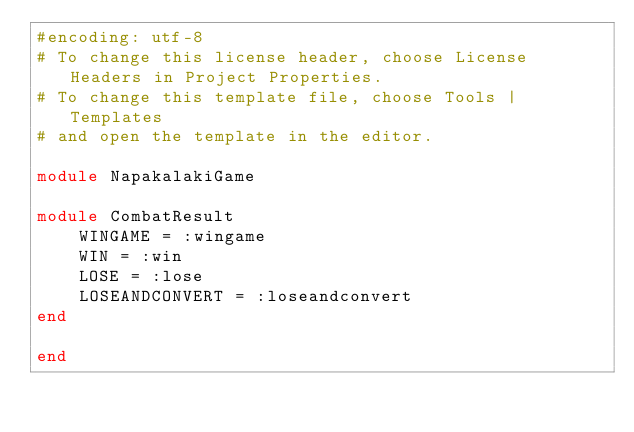Convert code to text. <code><loc_0><loc_0><loc_500><loc_500><_Ruby_>#encoding: utf-8
# To change this license header, choose License Headers in Project Properties.
# To change this template file, choose Tools | Templates
# and open the template in the editor.

module NapakalakiGame

module CombatResult
    WINGAME = :wingame
    WIN = :win
    LOSE = :lose
    LOSEANDCONVERT = :loseandconvert
end

end</code> 